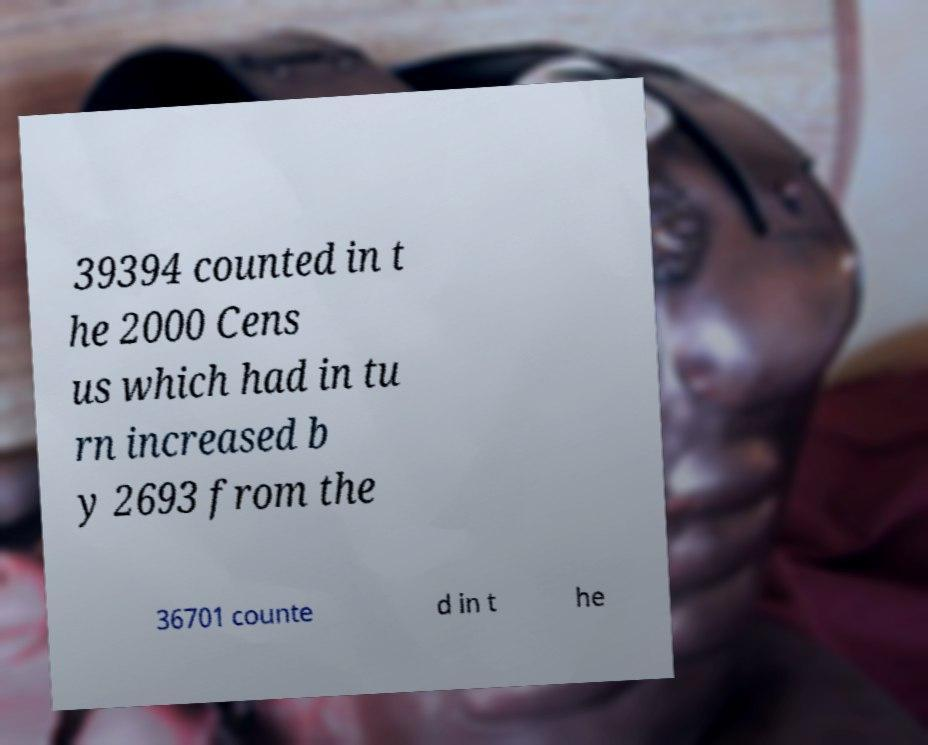I need the written content from this picture converted into text. Can you do that? 39394 counted in t he 2000 Cens us which had in tu rn increased b y 2693 from the 36701 counte d in t he 